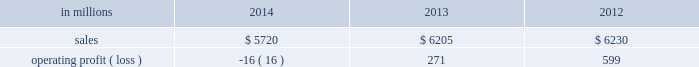Regions .
Principal cost drivers include manufacturing efficiency , raw material and energy costs and freight costs .
Printing papers net sales for 2014 decreased 8% ( 8 % ) to $ 5.7 billion compared with $ 6.2 billion in 2013 and 8% ( 8 % ) compared with $ 6.2 billion in 2012 .
Operating profits in 2014 were 106% ( 106 % ) lower than in 2013 and 103% ( 103 % ) lower than in 2012 .
Excluding facility closure costs , impairment costs and other special items , operating profits in 2014 were 7% ( 7 % ) higher than in 2013 and 8% ( 8 % ) lower than in 2012 .
Benefits from higher average sales price realizations and a favorable mix ( $ 178 million ) , lower planned maintenance downtime costs ( $ 26 million ) , the absence of a provision for bad debt related to a large envelope customer that was booked in 2013 ( $ 28 million ) , and lower foreign exchange and other costs ( $ 25 million ) were offset by lower sales volumes ( $ 82 million ) , higher operating costs ( $ 49 million ) , higher input costs ( $ 47 million ) , and costs associated with the closure of our courtland , alabama mill ( $ 41 million ) .
In addition , operating profits in 2014 include special items costs of $ 554 million associated with the closure of our courtland , alabama mill .
During 2013 , the company accelerated depreciation for certain courtland assets , and evaluated certain other assets for possible alternative uses by one of our other businesses .
The net book value of these assets at december 31 , 2013 was approximately $ 470 million .
In the first quarter of 2014 , we completed our evaluation and concluded that there were no alternative uses for these assets .
We recognized approximately $ 464 million of accelerated depreciation related to these assets in 2014 .
Operating profits in 2014 also include a charge of $ 32 million associated with a foreign tax amnesty program , and a gain of $ 20 million for the resolution of a legal contingency in india , while operating profits in 2013 included costs of $ 118 million associated with the announced closure of our courtland , alabama mill and a $ 123 million impairment charge associated with goodwill and a trade name intangible asset in our india papers business .
Printing papers .
North american printing papers net sales were $ 2.1 billion in 2014 , $ 2.6 billion in 2013 and $ 2.7 billion in 2012 .
Operating profits in 2014 were a loss of $ 398 million ( a gain of $ 156 million excluding costs associated with the shutdown of our courtland , alabama mill ) compared with gains of $ 36 million ( $ 154 million excluding costs associated with the courtland mill shutdown ) in 2013 and $ 331 million in 2012 .
Sales volumes in 2014 decreased compared with 2013 due to lower market demand for uncoated freesheet paper and the closure our courtland mill .
Average sales price realizations were higher , reflecting sales price increases in both domestic and export markets .
Higher input costs for wood were offset by lower costs for chemicals , however freight costs were higher .
Planned maintenance downtime costs were $ 14 million lower in 2014 .
Operating profits in 2014 were negatively impacted by costs associated with the shutdown of our courtland , alabama mill but benefited from the absence of a provision for bad debt related to a large envelope customer that was recorded in 2013 .
Entering the first quarter of 2015 , sales volumes are expected to be stable compared with the fourth quarter of 2014 .
Average sales margins should improve reflecting a more favorable mix although average sales price realizations are expected to be flat .
Input costs are expected to be stable .
Planned maintenance downtime costs are expected to be about $ 16 million lower with an outage scheduled in the 2015 first quarter at our georgetown mill compared with outages at our eastover and riverdale mills in the 2014 fourth quarter .
Brazilian papers net sales for 2014 were $ 1.1 billion compared with $ 1.1 billion in 2013 and $ 1.1 billion in 2012 .
Operating profits for 2014 were $ 177 million ( $ 209 million excluding costs associated with a tax amnesty program ) compared with $ 210 million in 2013 and $ 163 million in 2012 .
Sales volumes in 2014 were about flat compared with 2013 .
Average sales price realizations improved for domestic uncoated freesheet paper due to the realization of price increases implemented in the second half of 2013 and in 2014 .
Margins were favorably affected by an increased proportion of sales to the higher-margin domestic market .
Raw material costs increased for wood and chemicals .
Operating costs were higher than in 2013 and planned maintenance downtime costs were flat .
Looking ahead to 2015 , sales volumes in the first quarter are expected to decrease due to seasonally weaker customer demand for uncoated freesheet paper .
Average sales price improvements are expected to reflect the partial realization of announced sales price increases in the brazilian domestic market for uncoated freesheet paper .
Input costs are expected to be flat .
Planned maintenance outage costs should be $ 5 million lower with an outage scheduled at the luiz antonio mill in the first quarter .
European papers net sales in 2014 were $ 1.5 billion compared with $ 1.5 billion in 2013 and $ 1.4 billion in 2012 .
Operating profits in 2014 were $ 140 million compared with $ 167 million in 2013 and $ 179 million in compared with 2013 , sales volumes for uncoated freesheet paper in 2014 were slightly higher in both .
What percentage where brazilian papers net sales of printing papers sales in 2013? 
Computations: ((1.1 * 1000) / 6205)
Answer: 0.17728. Regions .
Principal cost drivers include manufacturing efficiency , raw material and energy costs and freight costs .
Printing papers net sales for 2014 decreased 8% ( 8 % ) to $ 5.7 billion compared with $ 6.2 billion in 2013 and 8% ( 8 % ) compared with $ 6.2 billion in 2012 .
Operating profits in 2014 were 106% ( 106 % ) lower than in 2013 and 103% ( 103 % ) lower than in 2012 .
Excluding facility closure costs , impairment costs and other special items , operating profits in 2014 were 7% ( 7 % ) higher than in 2013 and 8% ( 8 % ) lower than in 2012 .
Benefits from higher average sales price realizations and a favorable mix ( $ 178 million ) , lower planned maintenance downtime costs ( $ 26 million ) , the absence of a provision for bad debt related to a large envelope customer that was booked in 2013 ( $ 28 million ) , and lower foreign exchange and other costs ( $ 25 million ) were offset by lower sales volumes ( $ 82 million ) , higher operating costs ( $ 49 million ) , higher input costs ( $ 47 million ) , and costs associated with the closure of our courtland , alabama mill ( $ 41 million ) .
In addition , operating profits in 2014 include special items costs of $ 554 million associated with the closure of our courtland , alabama mill .
During 2013 , the company accelerated depreciation for certain courtland assets , and evaluated certain other assets for possible alternative uses by one of our other businesses .
The net book value of these assets at december 31 , 2013 was approximately $ 470 million .
In the first quarter of 2014 , we completed our evaluation and concluded that there were no alternative uses for these assets .
We recognized approximately $ 464 million of accelerated depreciation related to these assets in 2014 .
Operating profits in 2014 also include a charge of $ 32 million associated with a foreign tax amnesty program , and a gain of $ 20 million for the resolution of a legal contingency in india , while operating profits in 2013 included costs of $ 118 million associated with the announced closure of our courtland , alabama mill and a $ 123 million impairment charge associated with goodwill and a trade name intangible asset in our india papers business .
Printing papers .
North american printing papers net sales were $ 2.1 billion in 2014 , $ 2.6 billion in 2013 and $ 2.7 billion in 2012 .
Operating profits in 2014 were a loss of $ 398 million ( a gain of $ 156 million excluding costs associated with the shutdown of our courtland , alabama mill ) compared with gains of $ 36 million ( $ 154 million excluding costs associated with the courtland mill shutdown ) in 2013 and $ 331 million in 2012 .
Sales volumes in 2014 decreased compared with 2013 due to lower market demand for uncoated freesheet paper and the closure our courtland mill .
Average sales price realizations were higher , reflecting sales price increases in both domestic and export markets .
Higher input costs for wood were offset by lower costs for chemicals , however freight costs were higher .
Planned maintenance downtime costs were $ 14 million lower in 2014 .
Operating profits in 2014 were negatively impacted by costs associated with the shutdown of our courtland , alabama mill but benefited from the absence of a provision for bad debt related to a large envelope customer that was recorded in 2013 .
Entering the first quarter of 2015 , sales volumes are expected to be stable compared with the fourth quarter of 2014 .
Average sales margins should improve reflecting a more favorable mix although average sales price realizations are expected to be flat .
Input costs are expected to be stable .
Planned maintenance downtime costs are expected to be about $ 16 million lower with an outage scheduled in the 2015 first quarter at our georgetown mill compared with outages at our eastover and riverdale mills in the 2014 fourth quarter .
Brazilian papers net sales for 2014 were $ 1.1 billion compared with $ 1.1 billion in 2013 and $ 1.1 billion in 2012 .
Operating profits for 2014 were $ 177 million ( $ 209 million excluding costs associated with a tax amnesty program ) compared with $ 210 million in 2013 and $ 163 million in 2012 .
Sales volumes in 2014 were about flat compared with 2013 .
Average sales price realizations improved for domestic uncoated freesheet paper due to the realization of price increases implemented in the second half of 2013 and in 2014 .
Margins were favorably affected by an increased proportion of sales to the higher-margin domestic market .
Raw material costs increased for wood and chemicals .
Operating costs were higher than in 2013 and planned maintenance downtime costs were flat .
Looking ahead to 2015 , sales volumes in the first quarter are expected to decrease due to seasonally weaker customer demand for uncoated freesheet paper .
Average sales price improvements are expected to reflect the partial realization of announced sales price increases in the brazilian domestic market for uncoated freesheet paper .
Input costs are expected to be flat .
Planned maintenance outage costs should be $ 5 million lower with an outage scheduled at the luiz antonio mill in the first quarter .
European papers net sales in 2014 were $ 1.5 billion compared with $ 1.5 billion in 2013 and $ 1.4 billion in 2012 .
Operating profits in 2014 were $ 140 million compared with $ 167 million in 2013 and $ 179 million in compared with 2013 , sales volumes for uncoated freesheet paper in 2014 were slightly higher in both .
What percentage where brazilian papers net sales of printing papers sales in 2014? 
Computations: ((1.1 * 1000) / 5720)
Answer: 0.19231. 